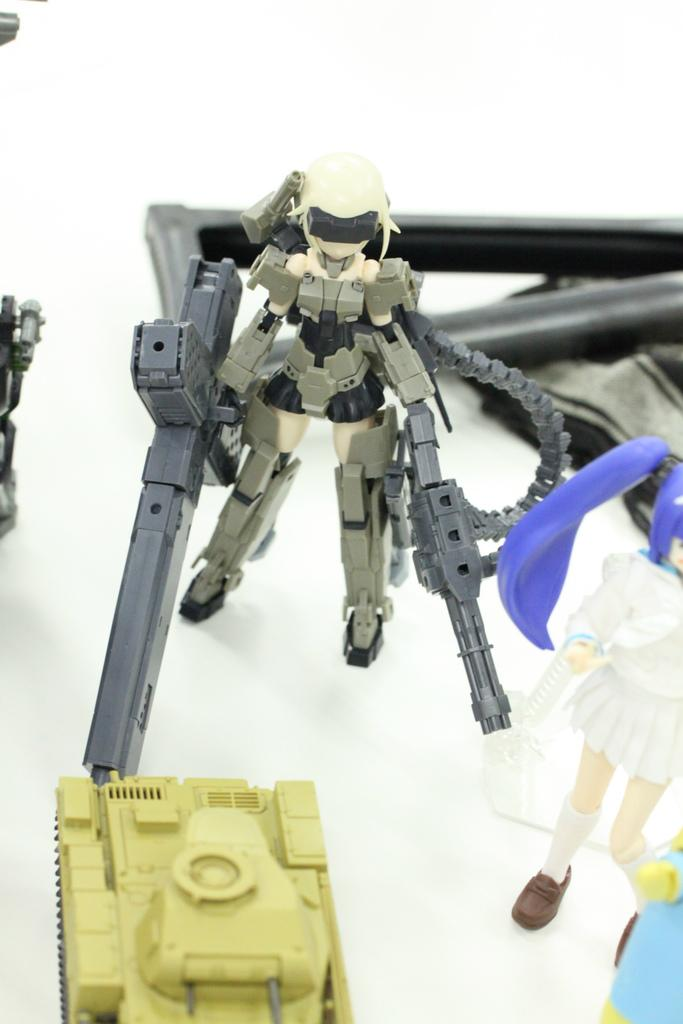What type of furniture is present in the image? There is a table in the image. What objects are on the table? There are toys on the table. Can you see any friends playing with the toys in the wilderness in the image? There is no mention of friends or wilderness in the image; it only features a table with toys on it. 